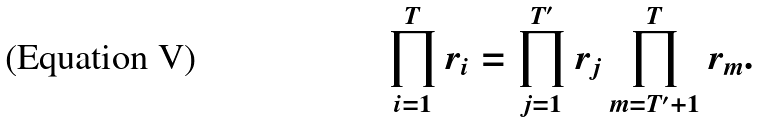Convert formula to latex. <formula><loc_0><loc_0><loc_500><loc_500>\prod _ { i = 1 } ^ { T } r _ { i } & = \prod _ { j = 1 } ^ { T ^ { \prime } } r _ { j } \prod _ { m = T ^ { \prime } + 1 } ^ { T } r _ { m } .</formula> 